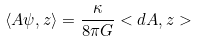Convert formula to latex. <formula><loc_0><loc_0><loc_500><loc_500>\left < A \psi , z \right > = \frac { \kappa } { 8 \pi G } < d A , z ></formula> 